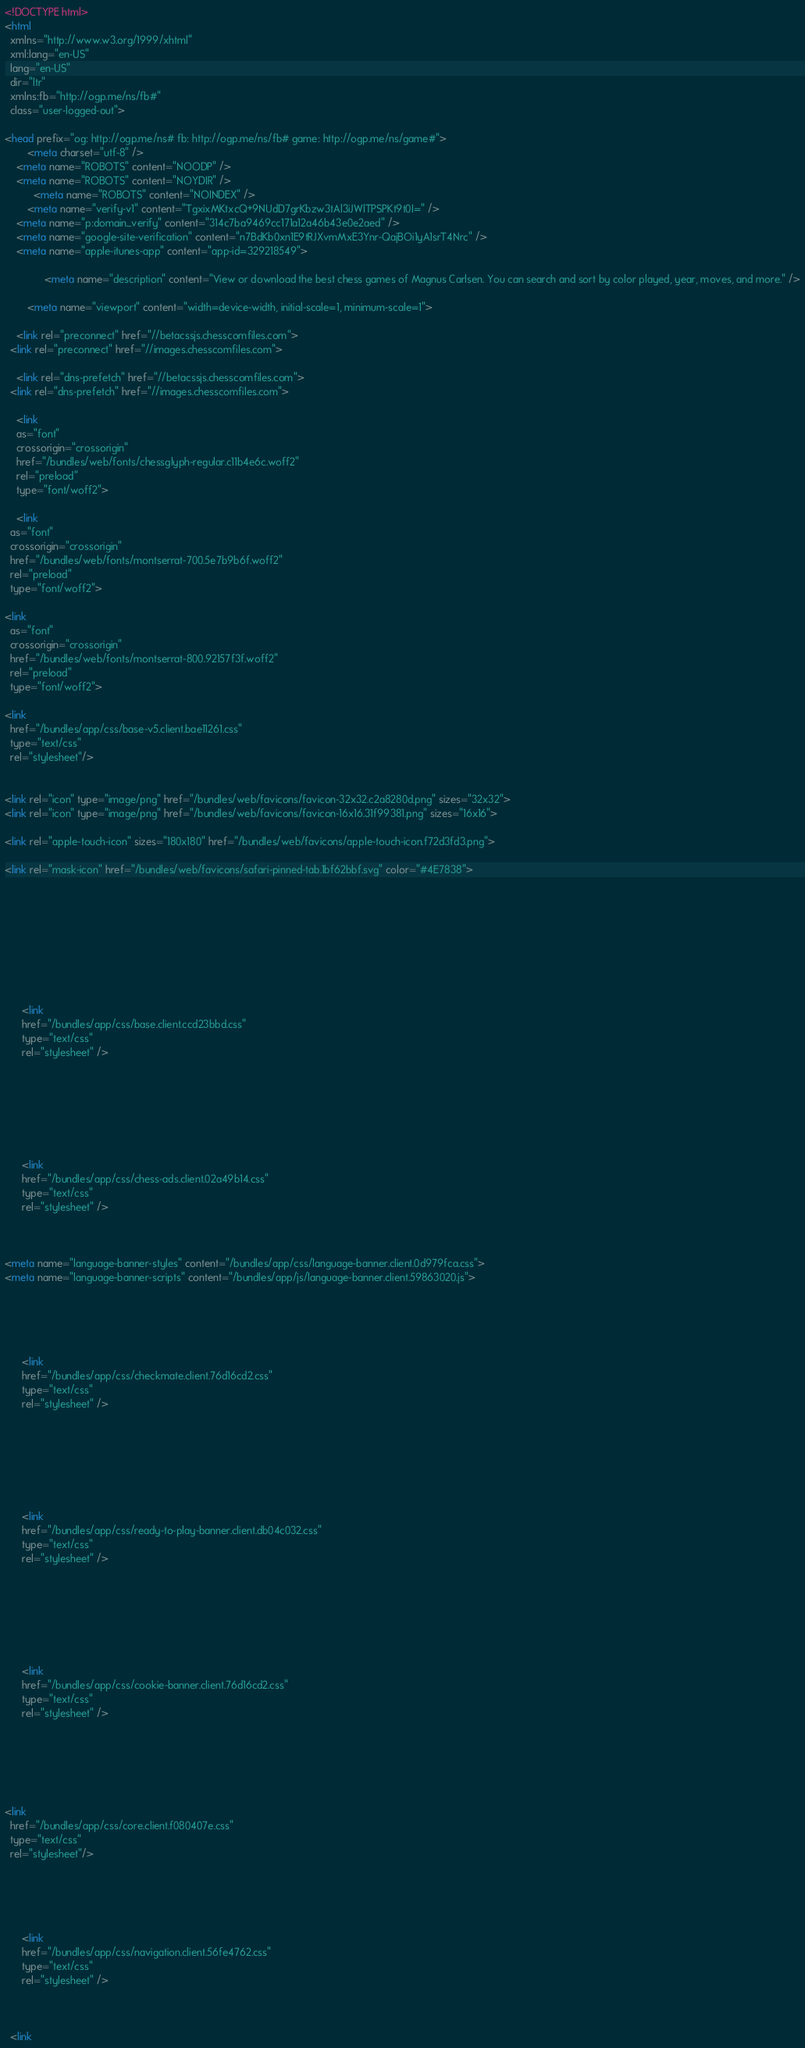Convert code to text. <code><loc_0><loc_0><loc_500><loc_500><_HTML_>










<!DOCTYPE html>
<html
  xmlns="http://www.w3.org/1999/xhtml"
  xml:lang="en-US"
  lang="en-US"
  dir="ltr"
  xmlns:fb="http://ogp.me/ns/fb#" 
  class="user-logged-out">

<head prefix="og: http://ogp.me/ns# fb: http://ogp.me/ns/fb# game: http://ogp.me/ns/game#">
        <meta charset="utf-8" />
    <meta name="ROBOTS" content="NOODP" />
    <meta name="ROBOTS" content="NOYDIR" />
          <meta name="ROBOTS" content="NOINDEX" />
        <meta name="verify-v1" content="TgxixMKtxcQ+9NUdD7grKbzw3tAl3iJWlTPSPKt9t0I=" />
    <meta name="p:domain_verify" content="314c7ba9469cc171a12a46b43e0e2aed" />
    <meta name="google-site-verification" content="n7BdKb0xn1E9tRJXvmMxE3Ynr-QajBOi1yA1srT4Nrc" />
    <meta name="apple-itunes-app" content="app-id=329218549">
  
              <meta name="description" content="View or download the best chess games of Magnus Carlsen. You can search and sort by color played, year, moves, and more." />
      
        <meta name="viewport" content="width=device-width, initial-scale=1, minimum-scale=1">
  
    <link rel="preconnect" href="//betacssjs.chesscomfiles.com">
  <link rel="preconnect" href="//images.chesscomfiles.com">

    <link rel="dns-prefetch" href="//betacssjs.chesscomfiles.com">
  <link rel="dns-prefetch" href="//images.chesscomfiles.com">

    <link
    as="font"
    crossorigin="crossorigin"
    href="/bundles/web/fonts/chessglyph-regular.c11b4e6c.woff2"
    rel="preload"
    type="font/woff2">

    <link
  as="font"
  crossorigin="crossorigin"
  href="/bundles/web/fonts/montserrat-700.5e7b9b6f.woff2"
  rel="preload"
  type="font/woff2">

<link
  as="font"
  crossorigin="crossorigin"
  href="/bundles/web/fonts/montserrat-800.92157f3f.woff2"
  rel="preload"
  type="font/woff2">

<link
  href="/bundles/app/css/base-v5.client.bae11261.css"
  type="text/css"
  rel="stylesheet"/>

        
<link rel="icon" type="image/png" href="/bundles/web/favicons/favicon-32x32.c2a8280d.png" sizes="32x32">
<link rel="icon" type="image/png" href="/bundles/web/favicons/favicon-16x16.31f99381.png" sizes="16x16">

<link rel="apple-touch-icon" sizes="180x180" href="/bundles/web/favicons/apple-touch-icon.f72d3fd3.png">

<link rel="mask-icon" href="/bundles/web/favicons/safari-pinned-tab.1bf62bbf.svg" color="#4E7838">

    



    
          
  
  
      <link
      href="/bundles/app/css/base.client.ccd23bbd.css"
      type="text/css"
      rel="stylesheet" />
  
  

        
          
  
  
      <link
      href="/bundles/app/css/chess-ads.client.02a49b14.css"
      type="text/css"
      rel="stylesheet" />
  
  
  
<meta name="language-banner-styles" content="/bundles/app/css/language-banner.client.0d979fca.css">
<meta name="language-banner-scripts" content="/bundles/app/js/language-banner.client.59863020.js">

    
          
  
  
      <link
      href="/bundles/app/css/checkmate.client.76d16cd2.css"
      type="text/css"
      rel="stylesheet" />
  
  

    
          
  
  
      <link
      href="/bundles/app/css/ready-to-play-banner.client.db04c032.css"
      type="text/css"
      rel="stylesheet" />
  
  

        
          
  
  
      <link
      href="/bundles/app/css/cookie-banner.client.76d16cd2.css"
      type="text/css"
      rel="stylesheet" />
  
  
  



<link
  href="/bundles/app/css/core.client.f080407e.css"
  type="text/css"
  rel="stylesheet"/>

    
          
  
  
      <link
      href="/bundles/app/css/navigation.client.56fe4762.css"
      type="text/css"
      rel="stylesheet" />
  
  

  <link</code> 